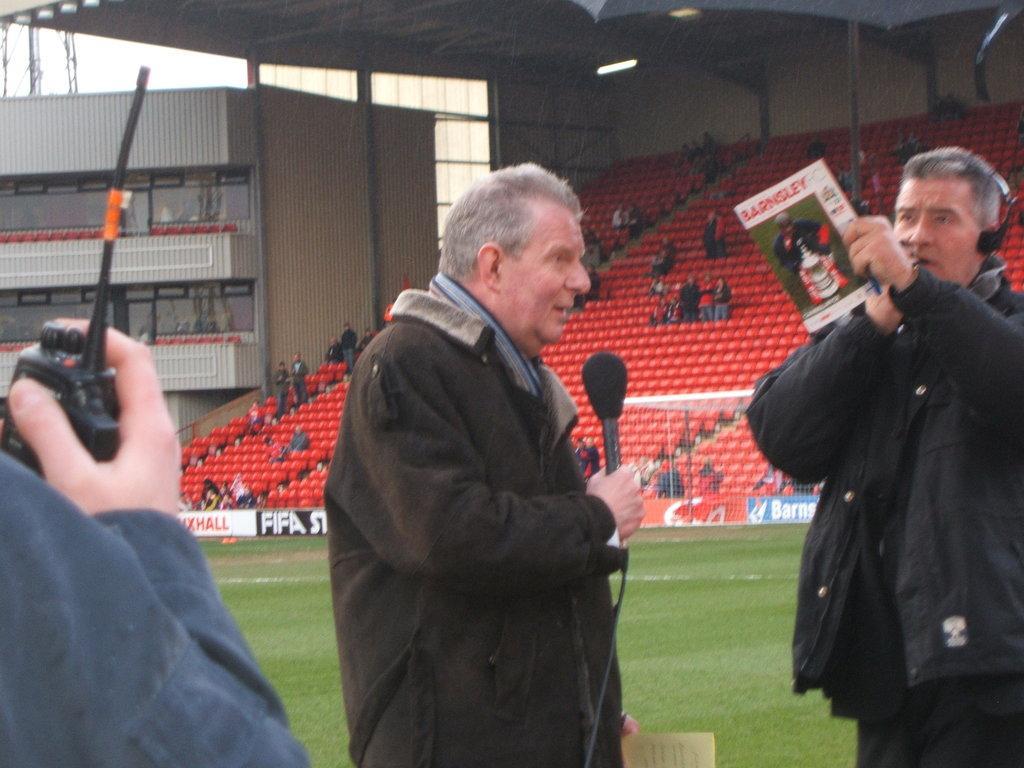Please provide a concise description of this image. This image is taken outdoors. This image is taken in a stadium. In the background there are many empty chairs and a few people are sitting on the chairs and a few are standing. There are many boards with a text on them. There is a building with walls. At the top of the image there is a roof. On the left side of the image a person is holding a walkie-talkie. In the middle of the image a man is standing and talking. He is holding a mic in his hand. On the right side of the image a man is standing and he is holding a book in his hand. 